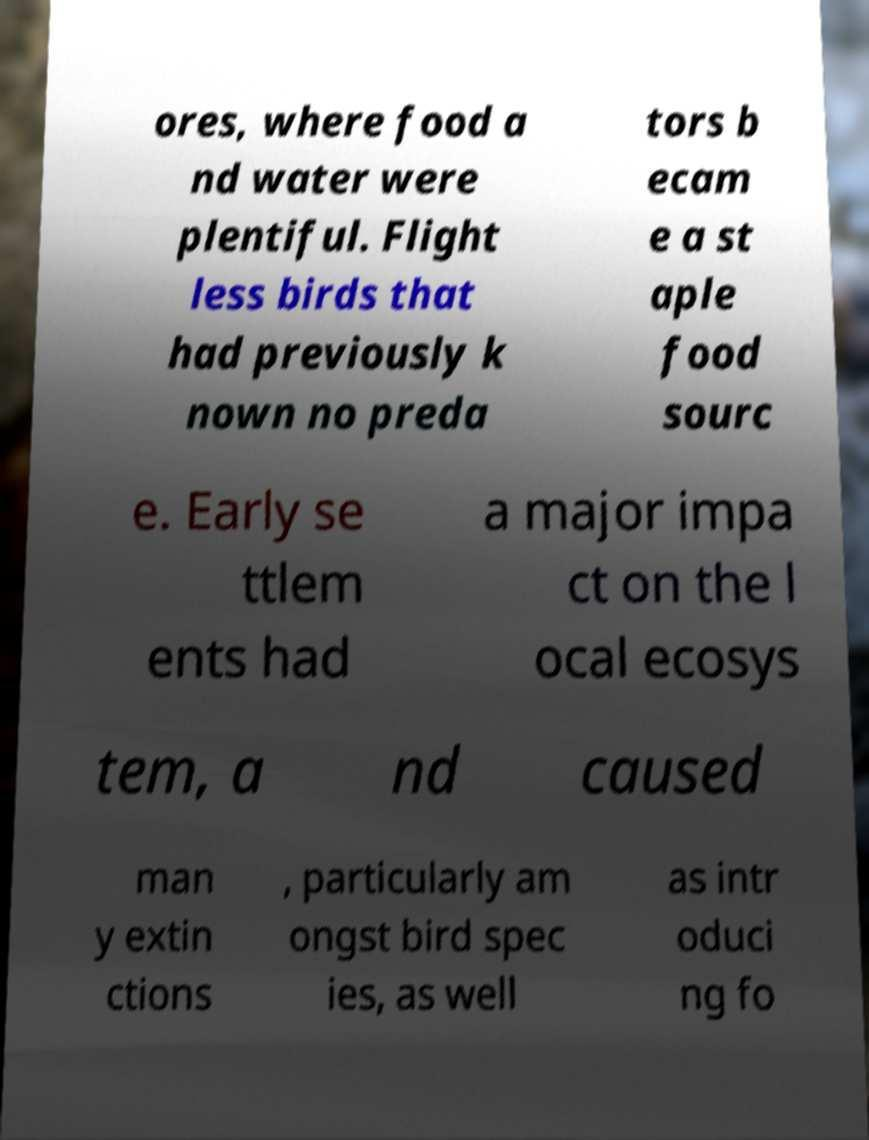Can you read and provide the text displayed in the image?This photo seems to have some interesting text. Can you extract and type it out for me? ores, where food a nd water were plentiful. Flight less birds that had previously k nown no preda tors b ecam e a st aple food sourc e. Early se ttlem ents had a major impa ct on the l ocal ecosys tem, a nd caused man y extin ctions , particularly am ongst bird spec ies, as well as intr oduci ng fo 